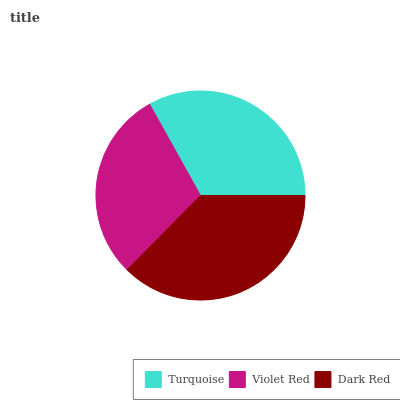Is Violet Red the minimum?
Answer yes or no. Yes. Is Dark Red the maximum?
Answer yes or no. Yes. Is Dark Red the minimum?
Answer yes or no. No. Is Violet Red the maximum?
Answer yes or no. No. Is Dark Red greater than Violet Red?
Answer yes or no. Yes. Is Violet Red less than Dark Red?
Answer yes or no. Yes. Is Violet Red greater than Dark Red?
Answer yes or no. No. Is Dark Red less than Violet Red?
Answer yes or no. No. Is Turquoise the high median?
Answer yes or no. Yes. Is Turquoise the low median?
Answer yes or no. Yes. Is Violet Red the high median?
Answer yes or no. No. Is Violet Red the low median?
Answer yes or no. No. 